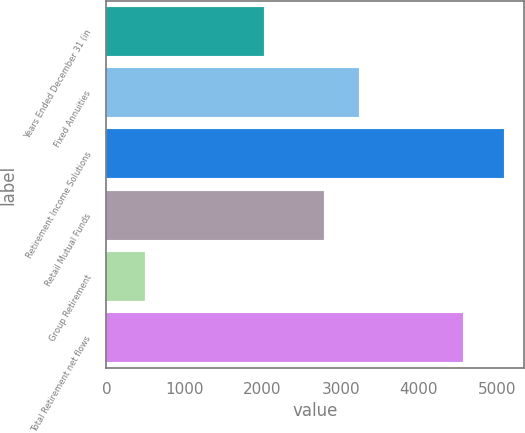Convert chart. <chart><loc_0><loc_0><loc_500><loc_500><bar_chart><fcel>Years Ended December 31 (in<fcel>Fixed Annuities<fcel>Retirement Income Solutions<fcel>Retail Mutual Funds<fcel>Group Retirement<fcel>Total Retirement net flows<nl><fcel>2013<fcel>3240<fcel>5092<fcel>2780<fcel>492<fcel>4560<nl></chart> 